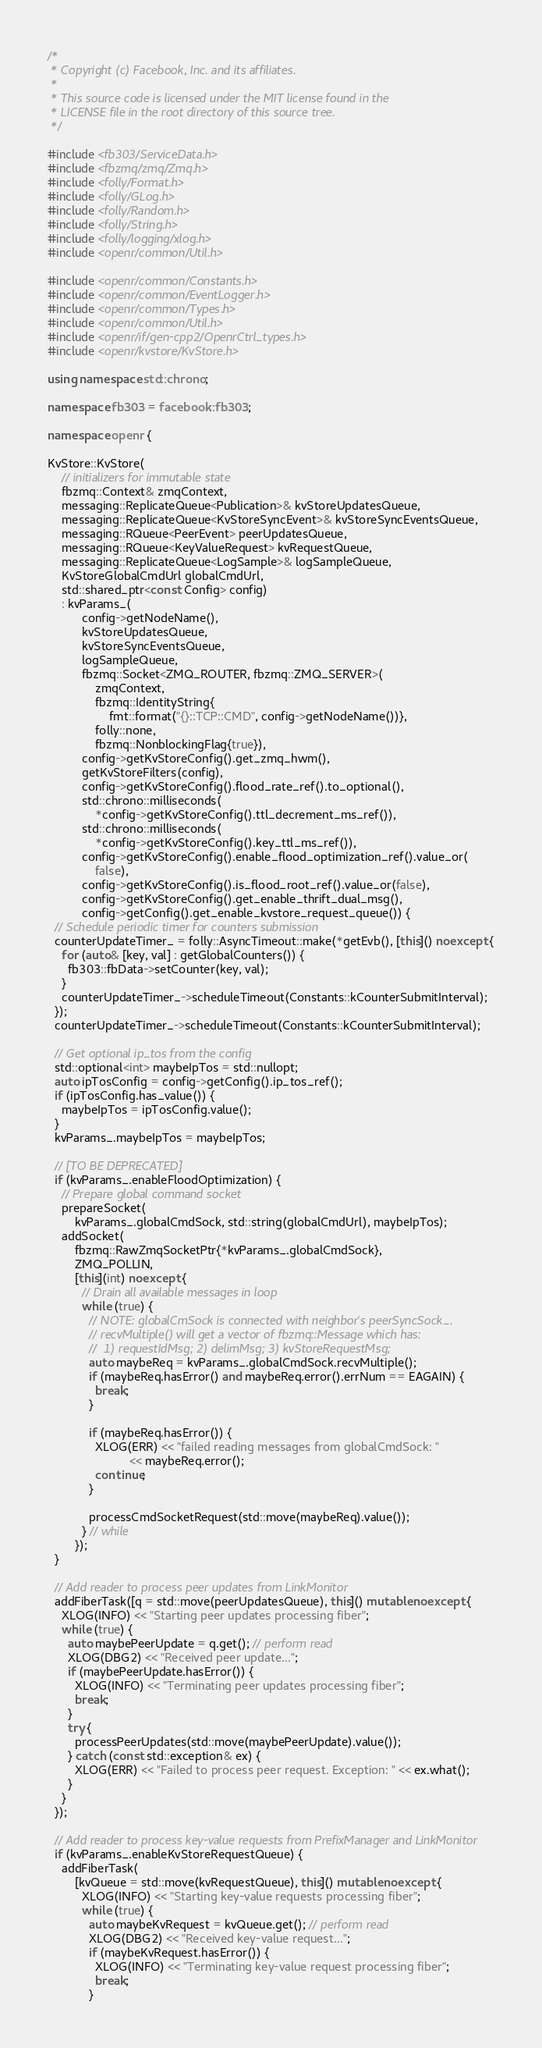<code> <loc_0><loc_0><loc_500><loc_500><_C++_>/*
 * Copyright (c) Facebook, Inc. and its affiliates.
 *
 * This source code is licensed under the MIT license found in the
 * LICENSE file in the root directory of this source tree.
 */

#include <fb303/ServiceData.h>
#include <fbzmq/zmq/Zmq.h>
#include <folly/Format.h>
#include <folly/GLog.h>
#include <folly/Random.h>
#include <folly/String.h>
#include <folly/logging/xlog.h>
#include <openr/common/Util.h>

#include <openr/common/Constants.h>
#include <openr/common/EventLogger.h>
#include <openr/common/Types.h>
#include <openr/common/Util.h>
#include <openr/if/gen-cpp2/OpenrCtrl_types.h>
#include <openr/kvstore/KvStore.h>

using namespace std::chrono;

namespace fb303 = facebook::fb303;

namespace openr {

KvStore::KvStore(
    // initializers for immutable state
    fbzmq::Context& zmqContext,
    messaging::ReplicateQueue<Publication>& kvStoreUpdatesQueue,
    messaging::ReplicateQueue<KvStoreSyncEvent>& kvStoreSyncEventsQueue,
    messaging::RQueue<PeerEvent> peerUpdatesQueue,
    messaging::RQueue<KeyValueRequest> kvRequestQueue,
    messaging::ReplicateQueue<LogSample>& logSampleQueue,
    KvStoreGlobalCmdUrl globalCmdUrl,
    std::shared_ptr<const Config> config)
    : kvParams_(
          config->getNodeName(),
          kvStoreUpdatesQueue,
          kvStoreSyncEventsQueue,
          logSampleQueue,
          fbzmq::Socket<ZMQ_ROUTER, fbzmq::ZMQ_SERVER>(
              zmqContext,
              fbzmq::IdentityString{
                  fmt::format("{}::TCP::CMD", config->getNodeName())},
              folly::none,
              fbzmq::NonblockingFlag{true}),
          config->getKvStoreConfig().get_zmq_hwm(),
          getKvStoreFilters(config),
          config->getKvStoreConfig().flood_rate_ref().to_optional(),
          std::chrono::milliseconds(
              *config->getKvStoreConfig().ttl_decrement_ms_ref()),
          std::chrono::milliseconds(
              *config->getKvStoreConfig().key_ttl_ms_ref()),
          config->getKvStoreConfig().enable_flood_optimization_ref().value_or(
              false),
          config->getKvStoreConfig().is_flood_root_ref().value_or(false),
          config->getKvStoreConfig().get_enable_thrift_dual_msg(),
          config->getConfig().get_enable_kvstore_request_queue()) {
  // Schedule periodic timer for counters submission
  counterUpdateTimer_ = folly::AsyncTimeout::make(*getEvb(), [this]() noexcept {
    for (auto& [key, val] : getGlobalCounters()) {
      fb303::fbData->setCounter(key, val);
    }
    counterUpdateTimer_->scheduleTimeout(Constants::kCounterSubmitInterval);
  });
  counterUpdateTimer_->scheduleTimeout(Constants::kCounterSubmitInterval);

  // Get optional ip_tos from the config
  std::optional<int> maybeIpTos = std::nullopt;
  auto ipTosConfig = config->getConfig().ip_tos_ref();
  if (ipTosConfig.has_value()) {
    maybeIpTos = ipTosConfig.value();
  }
  kvParams_.maybeIpTos = maybeIpTos;

  // [TO BE DEPRECATED]
  if (kvParams_.enableFloodOptimization) {
    // Prepare global command socket
    prepareSocket(
        kvParams_.globalCmdSock, std::string(globalCmdUrl), maybeIpTos);
    addSocket(
        fbzmq::RawZmqSocketPtr{*kvParams_.globalCmdSock},
        ZMQ_POLLIN,
        [this](int) noexcept {
          // Drain all available messages in loop
          while (true) {
            // NOTE: globalCmSock is connected with neighbor's peerSyncSock_.
            // recvMultiple() will get a vector of fbzmq::Message which has:
            //  1) requestIdMsg; 2) delimMsg; 3) kvStoreRequestMsg;
            auto maybeReq = kvParams_.globalCmdSock.recvMultiple();
            if (maybeReq.hasError() and maybeReq.error().errNum == EAGAIN) {
              break;
            }

            if (maybeReq.hasError()) {
              XLOG(ERR) << "failed reading messages from globalCmdSock: "
                        << maybeReq.error();
              continue;
            }

            processCmdSocketRequest(std::move(maybeReq).value());
          } // while
        });
  }

  // Add reader to process peer updates from LinkMonitor
  addFiberTask([q = std::move(peerUpdatesQueue), this]() mutable noexcept {
    XLOG(INFO) << "Starting peer updates processing fiber";
    while (true) {
      auto maybePeerUpdate = q.get(); // perform read
      XLOG(DBG2) << "Received peer update...";
      if (maybePeerUpdate.hasError()) {
        XLOG(INFO) << "Terminating peer updates processing fiber";
        break;
      }
      try {
        processPeerUpdates(std::move(maybePeerUpdate).value());
      } catch (const std::exception& ex) {
        XLOG(ERR) << "Failed to process peer request. Exception: " << ex.what();
      }
    }
  });

  // Add reader to process key-value requests from PrefixManager and LinkMonitor
  if (kvParams_.enableKvStoreRequestQueue) {
    addFiberTask(
        [kvQueue = std::move(kvRequestQueue), this]() mutable noexcept {
          XLOG(INFO) << "Starting key-value requests processing fiber";
          while (true) {
            auto maybeKvRequest = kvQueue.get(); // perform read
            XLOG(DBG2) << "Received key-value request...";
            if (maybeKvRequest.hasError()) {
              XLOG(INFO) << "Terminating key-value request processing fiber";
              break;
            }</code> 